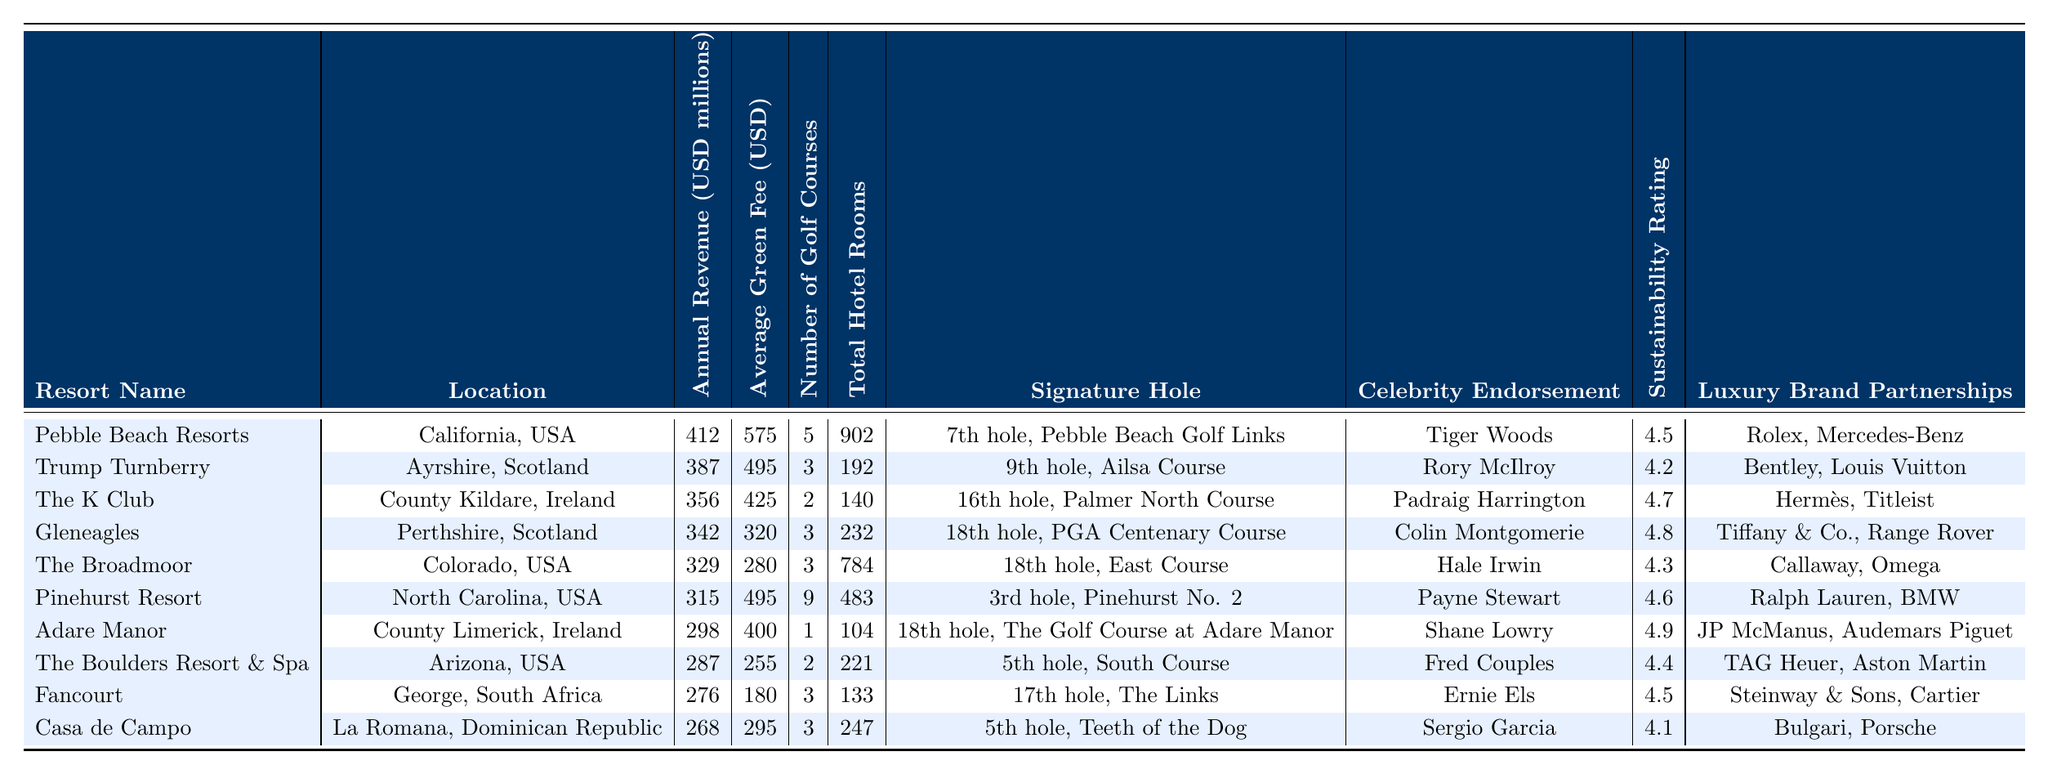What is the annual revenue of Pebble Beach Resorts? The table lists Pebble Beach Resorts with an annual revenue of 412 million USD.
Answer: 412 million USD Which resort has the highest average green fee? The average green fee for Pebble Beach Resorts is 575 USD, which is higher than any other resort listed.
Answer: Pebble Beach Resorts How many golf courses does Pinehurst Resort have? The table explicitly states that Pinehurst Resort has 9 golf courses.
Answer: 9 What is the total number of hotel rooms across the top three luxury golf resorts by revenue? The top three resorts are Pebble Beach Resorts (902 rooms), Trump Turnberry (192 rooms), and The K Club (140 rooms). The total is 902 + 192 + 140 = 1234 rooms.
Answer: 1234 rooms Is there a resort with a sustainability rating of 5 or higher? Checking the sustainability ratings, the highest rating is 4.9 at Adare Manor, so there is no resort with a rating of 5 or higher.
Answer: No Which resort has a signature hole named the "5th hole, Teeth of the Dog"? Casa de Campo is listed in the table as having the signature hole named "5th hole, Teeth of the Dog".
Answer: Casa de Campo What is the average sustainability rating of the top five resorts by revenue? The sustainability ratings of the top five are 4.5 (Pebble Beach), 4.2 (Trump Turnberry), 4.7 (The K Club), 4.8 (Gleneagles), and 4.3 (The Broadmoor). The sum is 4.5 + 4.2 + 4.7 + 4.8 + 4.3 = 22.5, and the average is 22.5 / 5 = 4.5.
Answer: 4.5 Which luxury brand partnerships are associated with Fancourt? The table shows that Fancourt has luxury brand partnerships with Steinway & Sons and Cartier.
Answer: Steinway & Sons, Cartier Does any resort feature a celebrity endorsement from Tiger Woods? Yes, Pebble Beach Resorts features a celebrity endorsement from Tiger Woods.
Answer: Yes What is the median annual revenue among the top 10 luxury golf resorts? The annual revenues in millions are: 412, 387, 356, 342, 329, 315, 298, 287, 276, 268. The median value (the average of the 5th and 6th largest revenues) is (329 + 315) / 2 = 322.
Answer: 322 million USD 